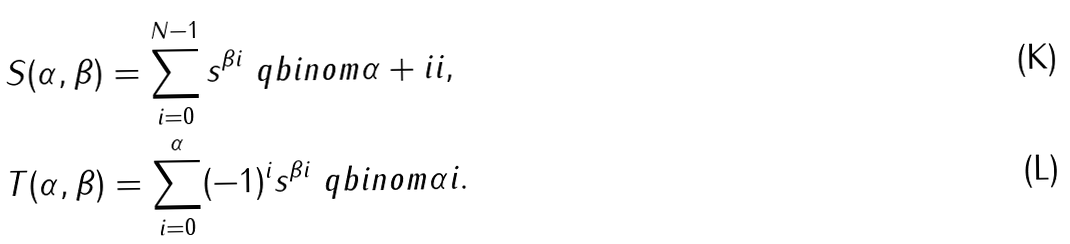Convert formula to latex. <formula><loc_0><loc_0><loc_500><loc_500>S ( \alpha , \beta ) & = \sum _ { i = 0 } ^ { N - 1 } s ^ { \beta i } \ q b i n o m { \alpha + i } { i } , \\ T ( \alpha , \beta ) & = \sum _ { i = 0 } ^ { \alpha } ( - 1 ) ^ { i } s ^ { \beta i } \ q b i n o m { \alpha } { i } .</formula> 